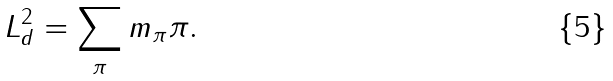Convert formula to latex. <formula><loc_0><loc_0><loc_500><loc_500>L ^ { 2 } _ { d } = \sum _ { \pi } m _ { \pi } \pi .</formula> 